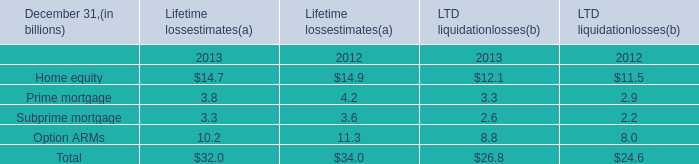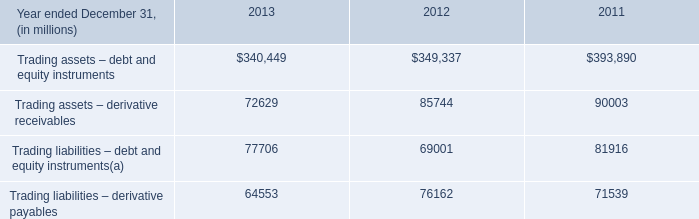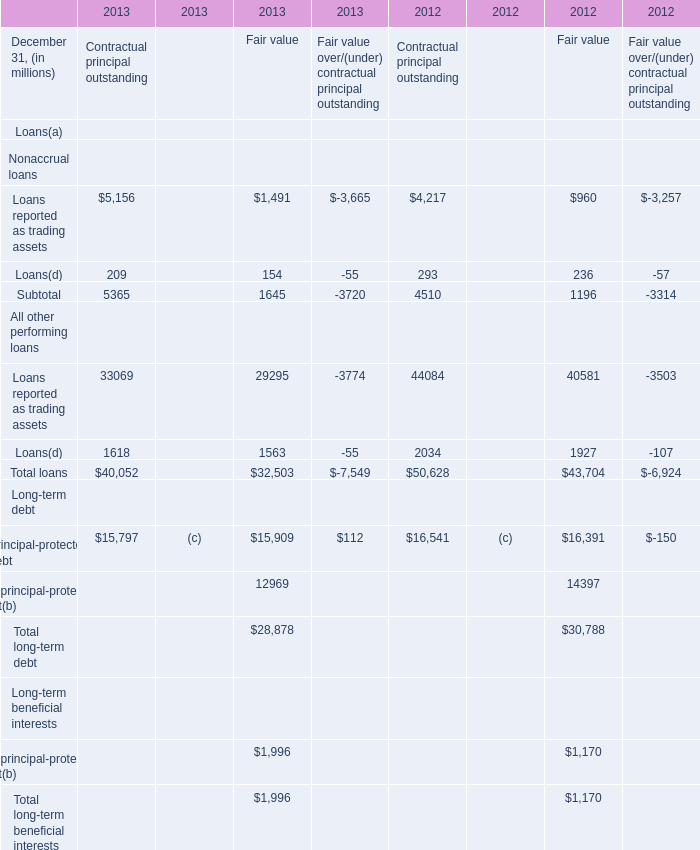What's the average of the Home equity for Lifetime lossestimates(a) in the years where Loans reported as trading assets for Contractual principal outstanding is positive? 
Computations: ((14.7 + 14.9) / 2)
Answer: 14.8. 